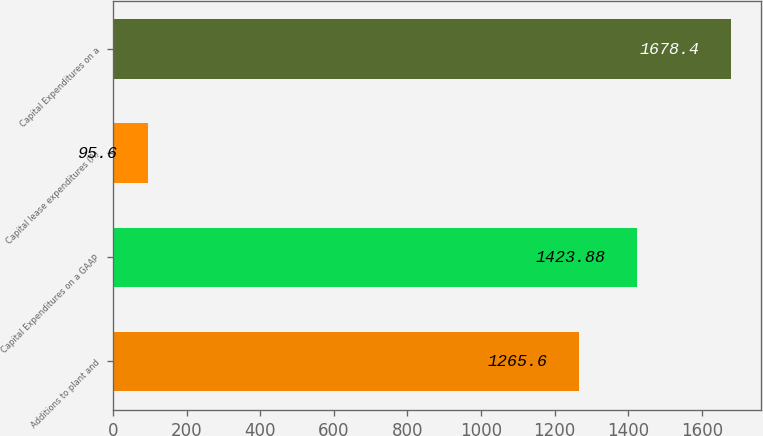Convert chart. <chart><loc_0><loc_0><loc_500><loc_500><bar_chart><fcel>Additions to plant and<fcel>Capital Expenditures on a GAAP<fcel>Capital lease expenditures (A)<fcel>Capital Expenditures on a<nl><fcel>1265.6<fcel>1423.88<fcel>95.6<fcel>1678.4<nl></chart> 